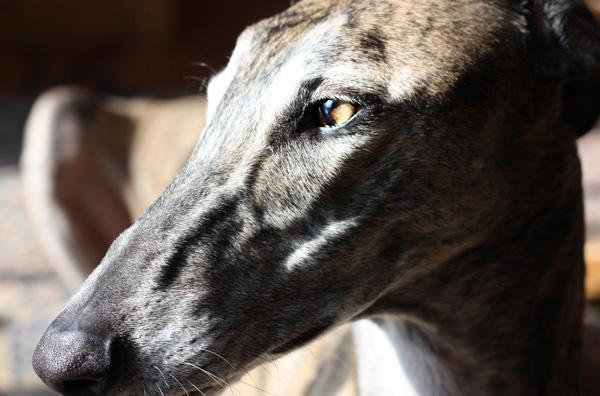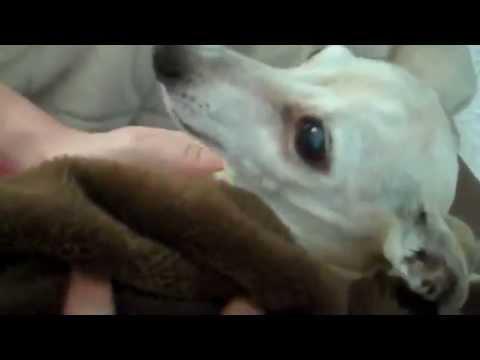The first image is the image on the left, the second image is the image on the right. Given the left and right images, does the statement "At least one of the dogs is on a leash." hold true? Answer yes or no. No. The first image is the image on the left, the second image is the image on the right. Evaluate the accuracy of this statement regarding the images: "At least one greyhound is wearing something red.". Is it true? Answer yes or no. No. 